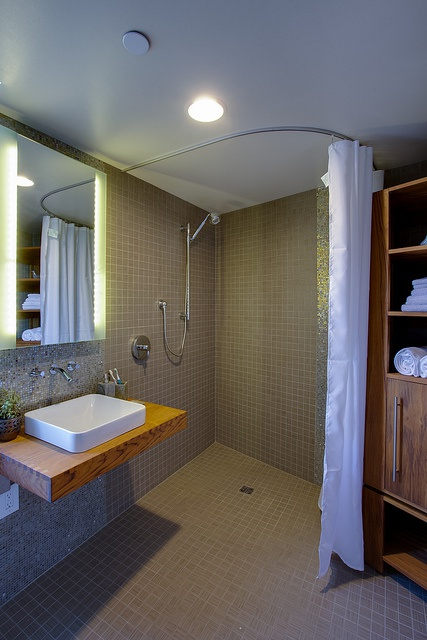Describe the objects in this image and their specific colors. I can see sink in gray, darkgray, lightblue, and lightgray tones, potted plant in gray, black, darkgreen, and maroon tones, toothbrush in gray and darkgray tones, and toothbrush in gray, blue, darkgray, and teal tones in this image. 